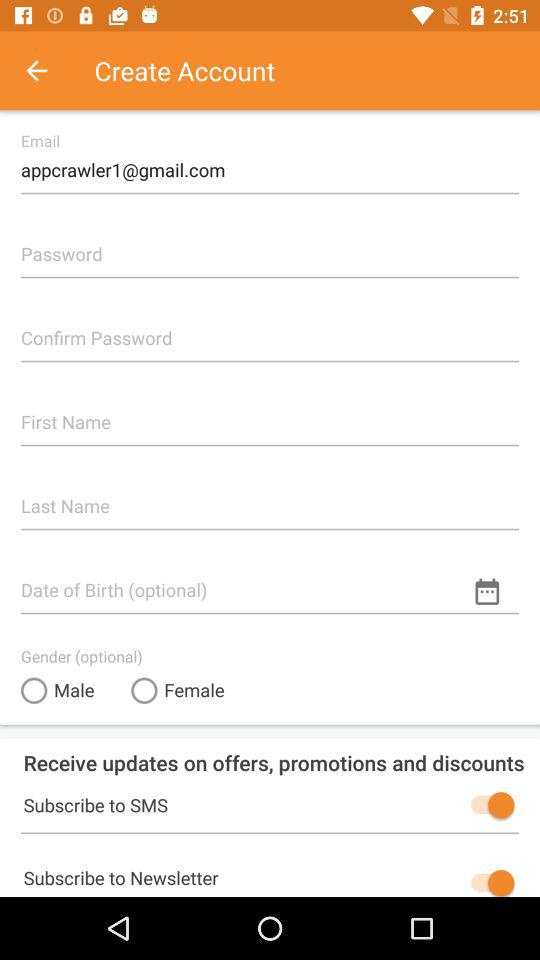What is the email address? The email address is appcrawler1@gmail.com. 